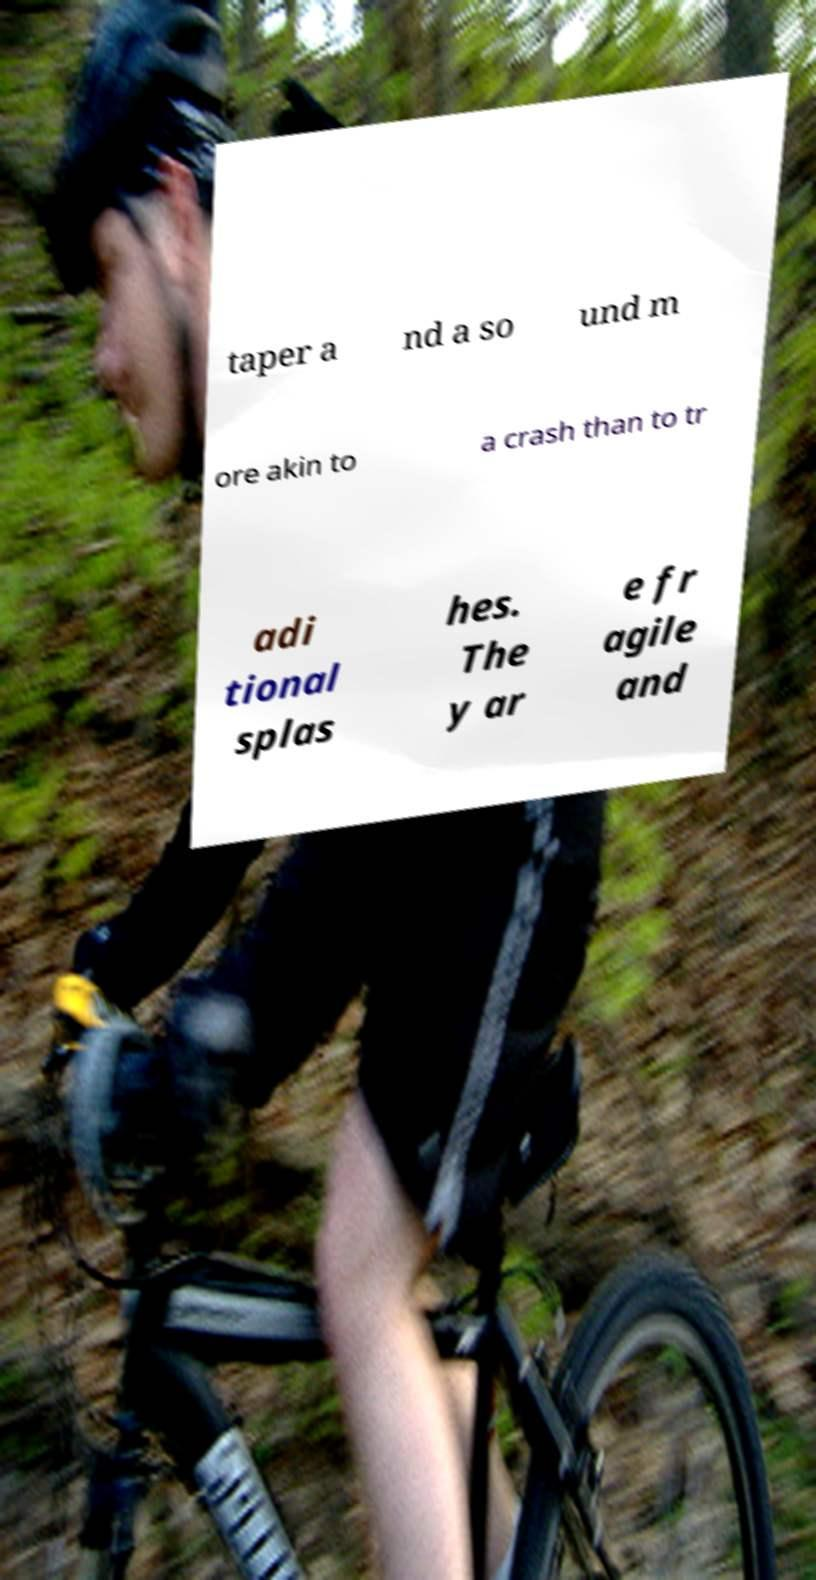What messages or text are displayed in this image? I need them in a readable, typed format. taper a nd a so und m ore akin to a crash than to tr adi tional splas hes. The y ar e fr agile and 